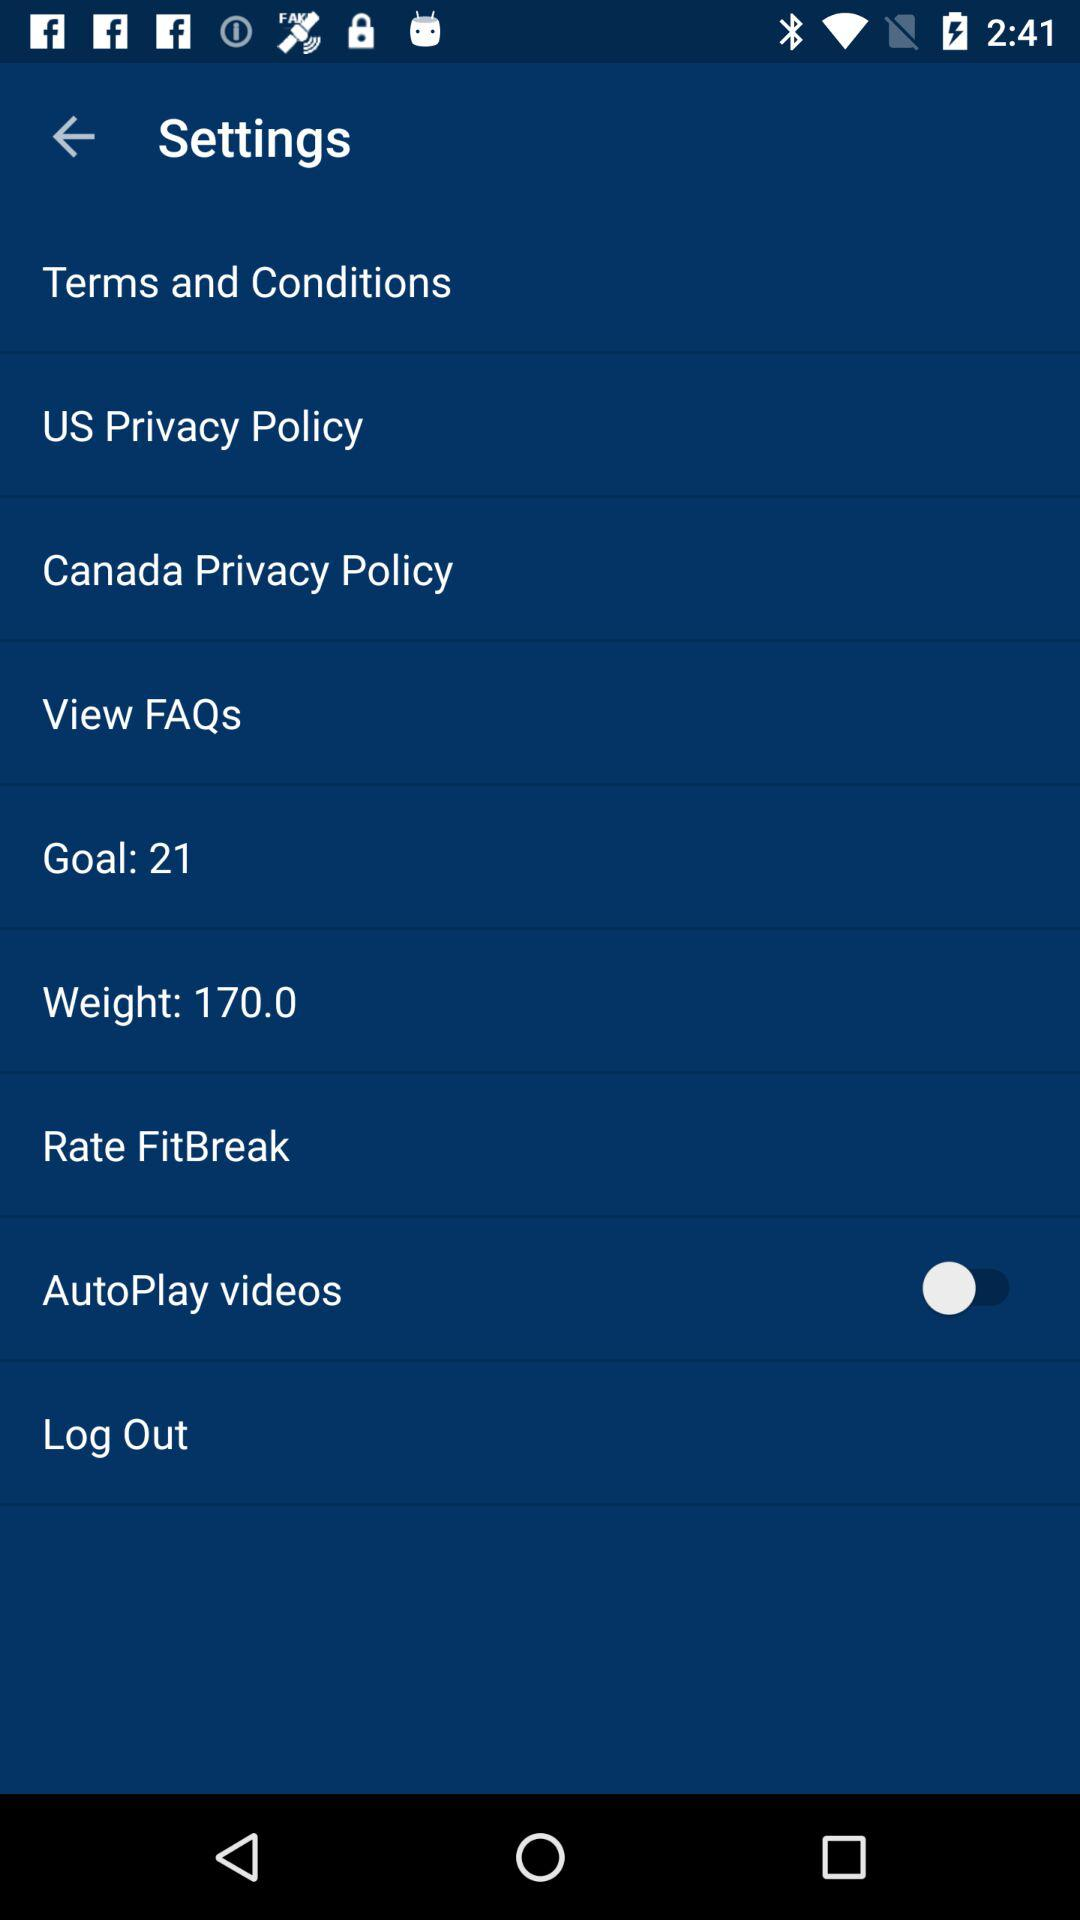What is the weight? The weight is 170. 